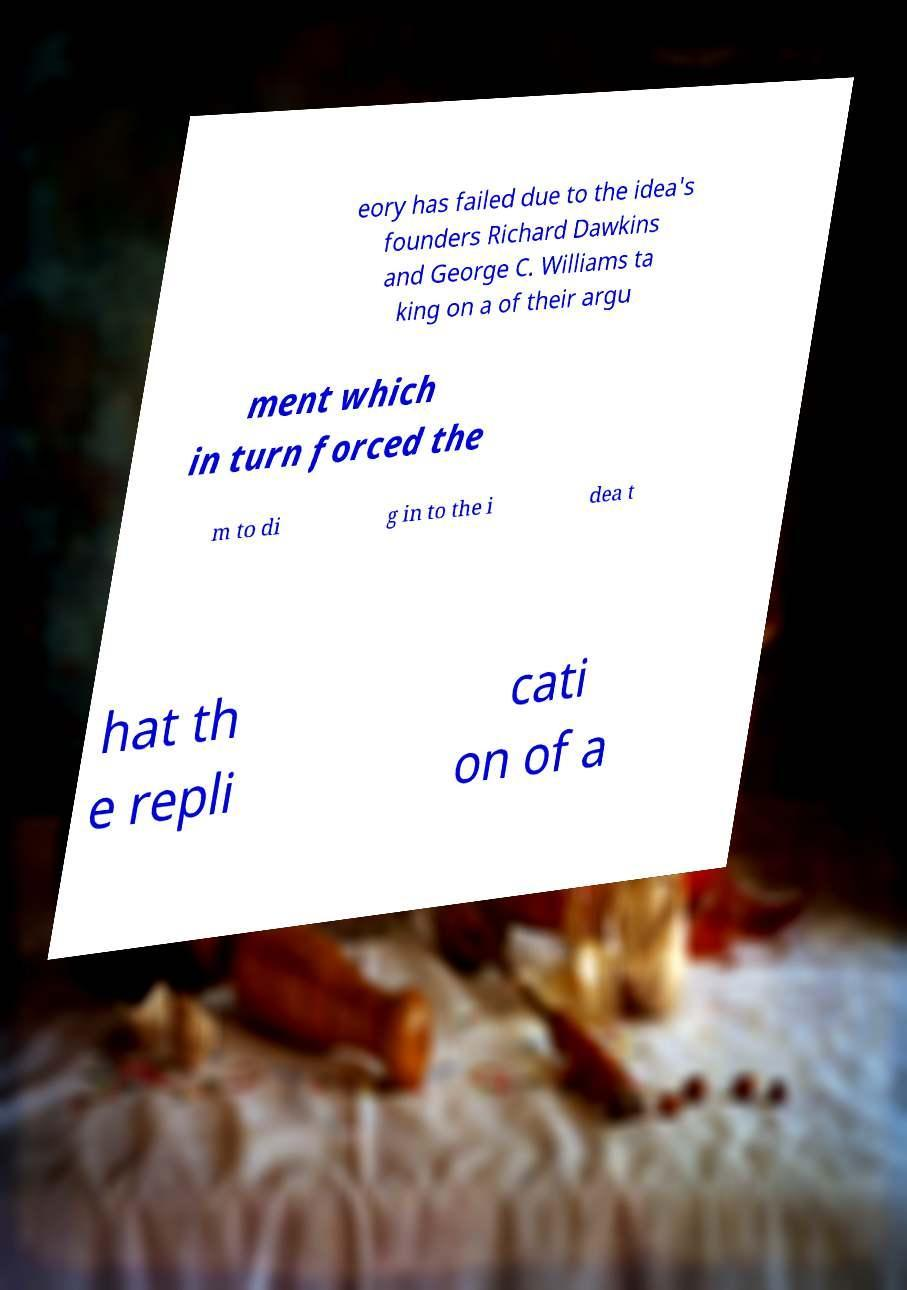I need the written content from this picture converted into text. Can you do that? eory has failed due to the idea's founders Richard Dawkins and George C. Williams ta king on a of their argu ment which in turn forced the m to di g in to the i dea t hat th e repli cati on of a 